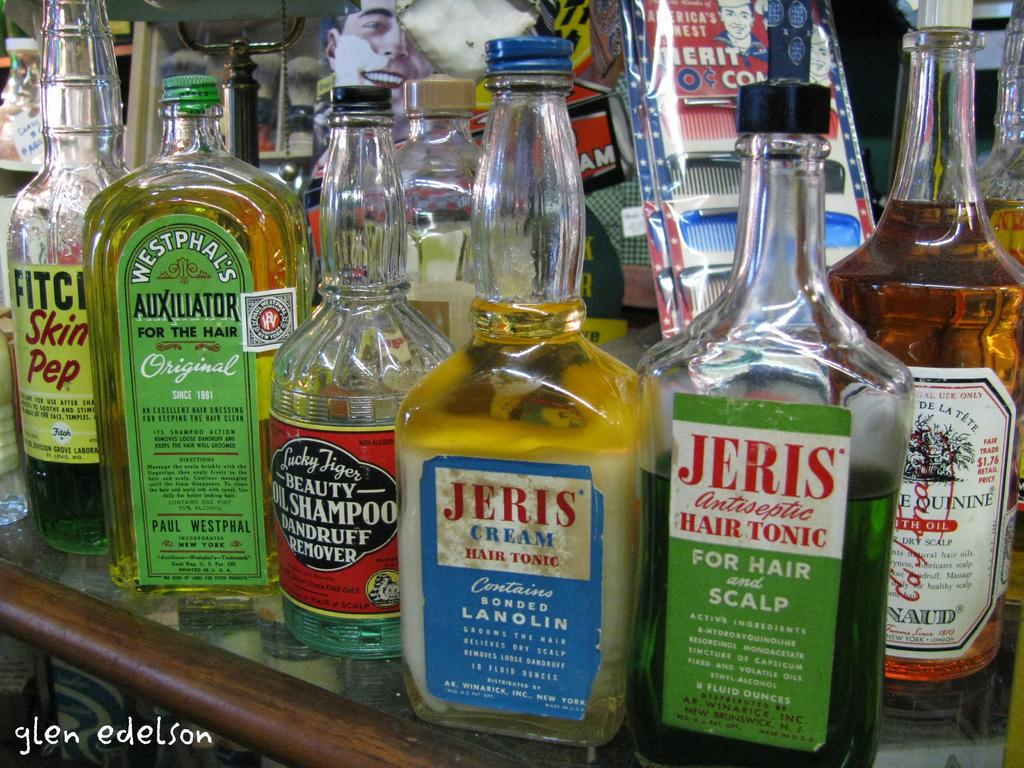What objects are visible in the image? There are different types of bottles in the image. Where are the bottles located? The bottles are placed on a shelf. What type of holiday is being celebrated in the image? There is no indication of a holiday being celebrated in the image, as it only features bottles on a shelf. 